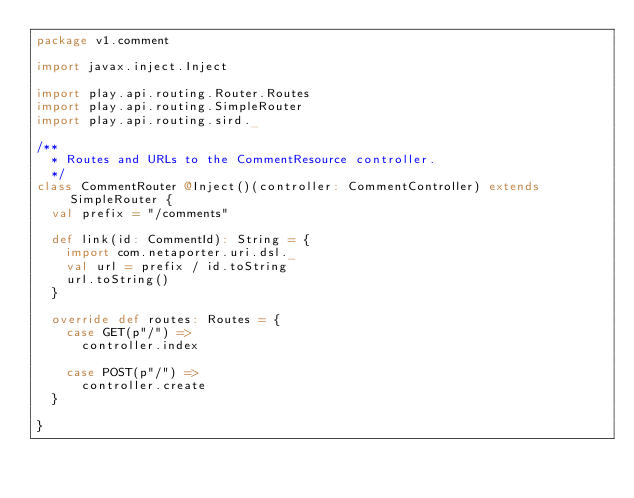Convert code to text. <code><loc_0><loc_0><loc_500><loc_500><_Scala_>package v1.comment

import javax.inject.Inject

import play.api.routing.Router.Routes
import play.api.routing.SimpleRouter
import play.api.routing.sird._

/**
  * Routes and URLs to the CommentResource controller.
  */
class CommentRouter @Inject()(controller: CommentController) extends SimpleRouter {
  val prefix = "/comments"

  def link(id: CommentId): String = {
    import com.netaporter.uri.dsl._
    val url = prefix / id.toString
    url.toString()
  }

  override def routes: Routes = {
    case GET(p"/") =>
      controller.index

    case POST(p"/") =>
      controller.create
  }

}
</code> 